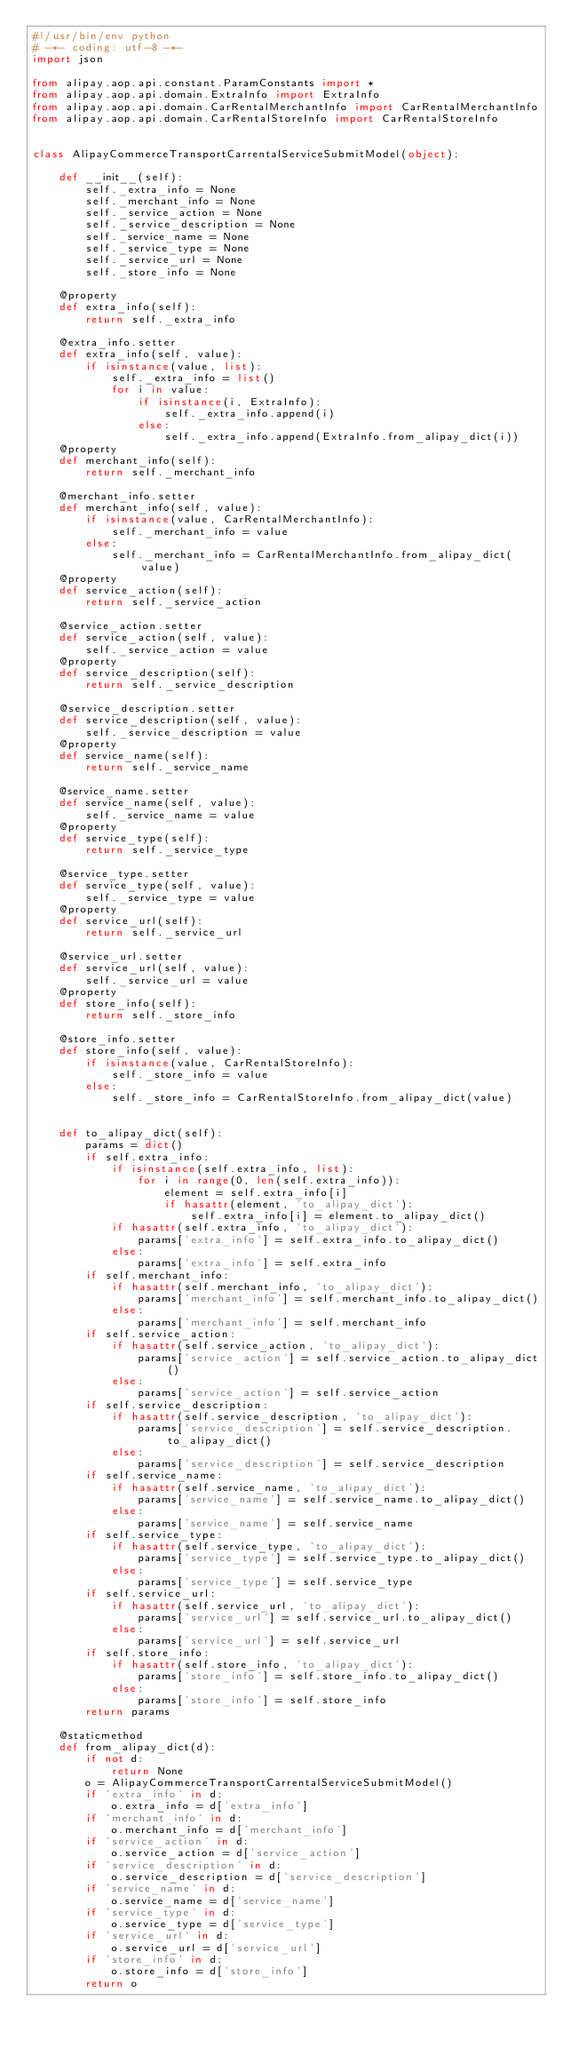Convert code to text. <code><loc_0><loc_0><loc_500><loc_500><_Python_>#!/usr/bin/env python
# -*- coding: utf-8 -*-
import json

from alipay.aop.api.constant.ParamConstants import *
from alipay.aop.api.domain.ExtraInfo import ExtraInfo
from alipay.aop.api.domain.CarRentalMerchantInfo import CarRentalMerchantInfo
from alipay.aop.api.domain.CarRentalStoreInfo import CarRentalStoreInfo


class AlipayCommerceTransportCarrentalServiceSubmitModel(object):

    def __init__(self):
        self._extra_info = None
        self._merchant_info = None
        self._service_action = None
        self._service_description = None
        self._service_name = None
        self._service_type = None
        self._service_url = None
        self._store_info = None

    @property
    def extra_info(self):
        return self._extra_info

    @extra_info.setter
    def extra_info(self, value):
        if isinstance(value, list):
            self._extra_info = list()
            for i in value:
                if isinstance(i, ExtraInfo):
                    self._extra_info.append(i)
                else:
                    self._extra_info.append(ExtraInfo.from_alipay_dict(i))
    @property
    def merchant_info(self):
        return self._merchant_info

    @merchant_info.setter
    def merchant_info(self, value):
        if isinstance(value, CarRentalMerchantInfo):
            self._merchant_info = value
        else:
            self._merchant_info = CarRentalMerchantInfo.from_alipay_dict(value)
    @property
    def service_action(self):
        return self._service_action

    @service_action.setter
    def service_action(self, value):
        self._service_action = value
    @property
    def service_description(self):
        return self._service_description

    @service_description.setter
    def service_description(self, value):
        self._service_description = value
    @property
    def service_name(self):
        return self._service_name

    @service_name.setter
    def service_name(self, value):
        self._service_name = value
    @property
    def service_type(self):
        return self._service_type

    @service_type.setter
    def service_type(self, value):
        self._service_type = value
    @property
    def service_url(self):
        return self._service_url

    @service_url.setter
    def service_url(self, value):
        self._service_url = value
    @property
    def store_info(self):
        return self._store_info

    @store_info.setter
    def store_info(self, value):
        if isinstance(value, CarRentalStoreInfo):
            self._store_info = value
        else:
            self._store_info = CarRentalStoreInfo.from_alipay_dict(value)


    def to_alipay_dict(self):
        params = dict()
        if self.extra_info:
            if isinstance(self.extra_info, list):
                for i in range(0, len(self.extra_info)):
                    element = self.extra_info[i]
                    if hasattr(element, 'to_alipay_dict'):
                        self.extra_info[i] = element.to_alipay_dict()
            if hasattr(self.extra_info, 'to_alipay_dict'):
                params['extra_info'] = self.extra_info.to_alipay_dict()
            else:
                params['extra_info'] = self.extra_info
        if self.merchant_info:
            if hasattr(self.merchant_info, 'to_alipay_dict'):
                params['merchant_info'] = self.merchant_info.to_alipay_dict()
            else:
                params['merchant_info'] = self.merchant_info
        if self.service_action:
            if hasattr(self.service_action, 'to_alipay_dict'):
                params['service_action'] = self.service_action.to_alipay_dict()
            else:
                params['service_action'] = self.service_action
        if self.service_description:
            if hasattr(self.service_description, 'to_alipay_dict'):
                params['service_description'] = self.service_description.to_alipay_dict()
            else:
                params['service_description'] = self.service_description
        if self.service_name:
            if hasattr(self.service_name, 'to_alipay_dict'):
                params['service_name'] = self.service_name.to_alipay_dict()
            else:
                params['service_name'] = self.service_name
        if self.service_type:
            if hasattr(self.service_type, 'to_alipay_dict'):
                params['service_type'] = self.service_type.to_alipay_dict()
            else:
                params['service_type'] = self.service_type
        if self.service_url:
            if hasattr(self.service_url, 'to_alipay_dict'):
                params['service_url'] = self.service_url.to_alipay_dict()
            else:
                params['service_url'] = self.service_url
        if self.store_info:
            if hasattr(self.store_info, 'to_alipay_dict'):
                params['store_info'] = self.store_info.to_alipay_dict()
            else:
                params['store_info'] = self.store_info
        return params

    @staticmethod
    def from_alipay_dict(d):
        if not d:
            return None
        o = AlipayCommerceTransportCarrentalServiceSubmitModel()
        if 'extra_info' in d:
            o.extra_info = d['extra_info']
        if 'merchant_info' in d:
            o.merchant_info = d['merchant_info']
        if 'service_action' in d:
            o.service_action = d['service_action']
        if 'service_description' in d:
            o.service_description = d['service_description']
        if 'service_name' in d:
            o.service_name = d['service_name']
        if 'service_type' in d:
            o.service_type = d['service_type']
        if 'service_url' in d:
            o.service_url = d['service_url']
        if 'store_info' in d:
            o.store_info = d['store_info']
        return o


</code> 